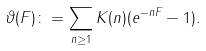<formula> <loc_0><loc_0><loc_500><loc_500>\vartheta ( F ) \colon = \sum _ { n \geq 1 } K ( n ) ( e ^ { - n F } - 1 ) .</formula> 